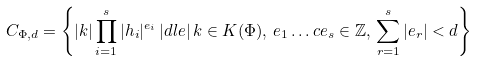Convert formula to latex. <formula><loc_0><loc_0><loc_500><loc_500>C _ { \Phi , d } = \left \{ | k | \prod _ { i = 1 } ^ { s } | h _ { i } | ^ { e _ { i } } \, | d l e | \, k \in K ( \Phi ) , \, e _ { 1 } \dots c e _ { s } \in { \mathbb { Z } } , \, \sum _ { r = 1 } ^ { s } | e _ { r } | < d \right \}</formula> 